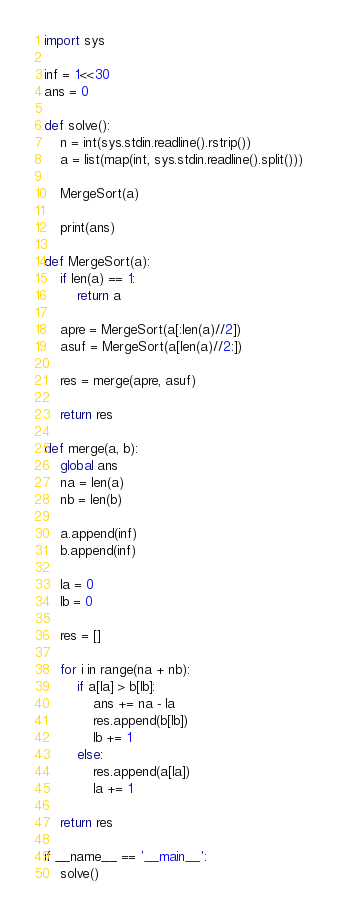<code> <loc_0><loc_0><loc_500><loc_500><_Python_>import sys

inf = 1<<30
ans = 0

def solve():
    n = int(sys.stdin.readline().rstrip())
    a = list(map(int, sys.stdin.readline().split()))

    MergeSort(a)

    print(ans)

def MergeSort(a):
    if len(a) == 1:
        return a

    apre = MergeSort(a[:len(a)//2])
    asuf = MergeSort(a[len(a)//2:])

    res = merge(apre, asuf)

    return res

def merge(a, b):
    global ans
    na = len(a)
    nb = len(b)

    a.append(inf)
    b.append(inf)

    la = 0
    lb = 0

    res = []

    for i in range(na + nb):
        if a[la] > b[lb]:
            ans += na - la
            res.append(b[lb])
            lb += 1
        else:
            res.append(a[la])
            la += 1

    return res

if __name__ == '__main__':
    solve()</code> 